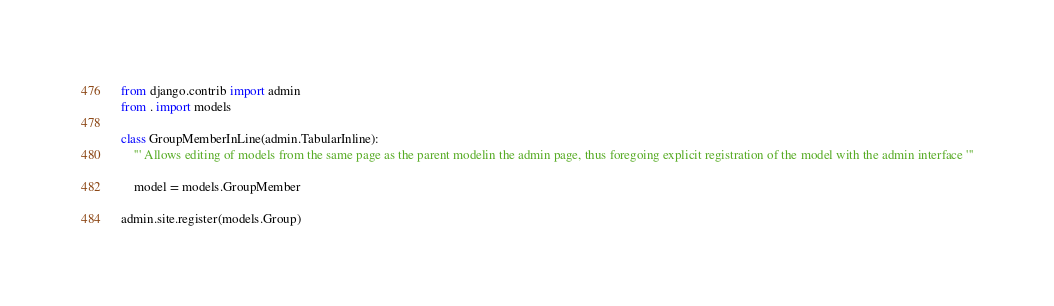Convert code to text. <code><loc_0><loc_0><loc_500><loc_500><_Python_>from django.contrib import admin
from . import models

class GroupMemberInLine(admin.TabularInline):
	''' Allows editing of models from the same page as the parent modelin the admin page, thus foregoing explicit registration of the model with the admin interface '''

	model = models.GroupMember

admin.site.register(models.Group)
</code> 